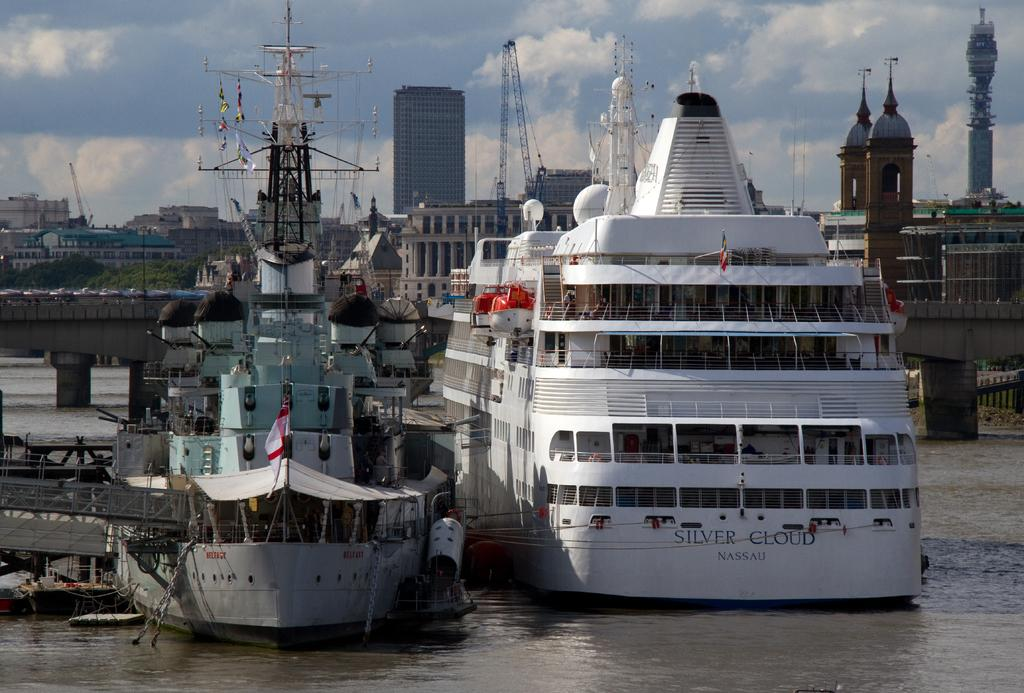<image>
Provide a brief description of the given image. A Silver Cloud cruise boat is docked next to a fishing boat. 